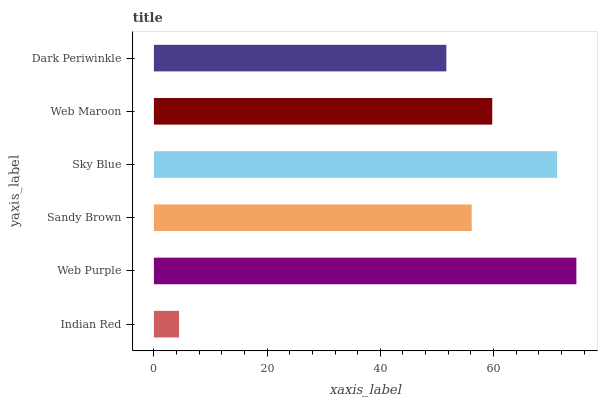Is Indian Red the minimum?
Answer yes or no. Yes. Is Web Purple the maximum?
Answer yes or no. Yes. Is Sandy Brown the minimum?
Answer yes or no. No. Is Sandy Brown the maximum?
Answer yes or no. No. Is Web Purple greater than Sandy Brown?
Answer yes or no. Yes. Is Sandy Brown less than Web Purple?
Answer yes or no. Yes. Is Sandy Brown greater than Web Purple?
Answer yes or no. No. Is Web Purple less than Sandy Brown?
Answer yes or no. No. Is Web Maroon the high median?
Answer yes or no. Yes. Is Sandy Brown the low median?
Answer yes or no. Yes. Is Sky Blue the high median?
Answer yes or no. No. Is Indian Red the low median?
Answer yes or no. No. 